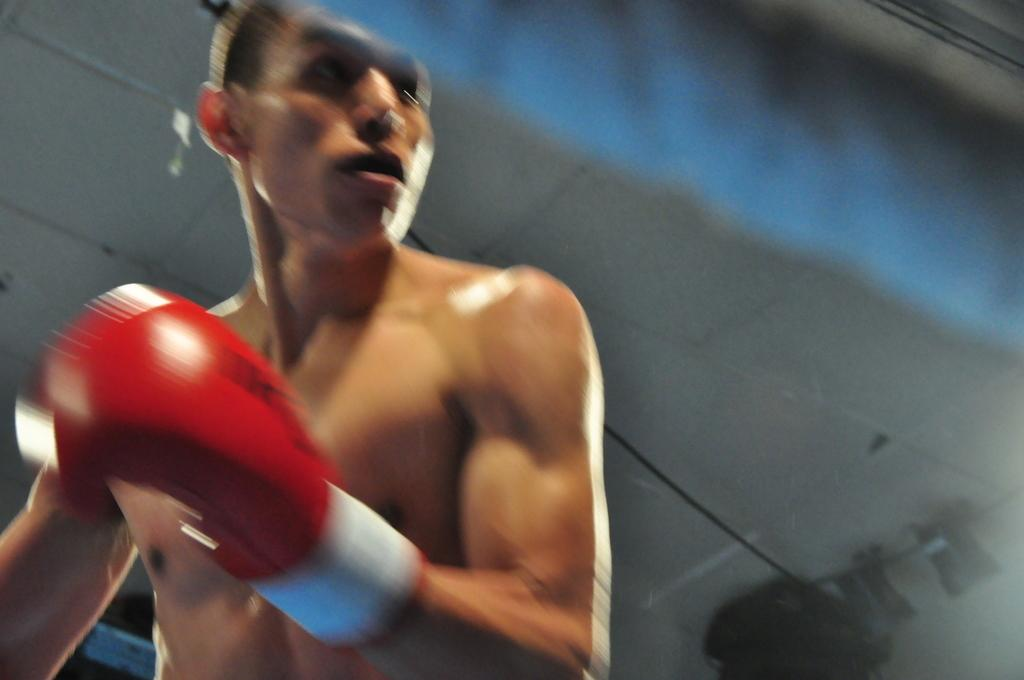Who or what is present in the image? There is a person in the image. What is the person wearing on their hand? The person is wearing a glove. Is the person in the image trying to escape from quicksand? There is no quicksand present in the image, so the person is not trying to escape from it. 